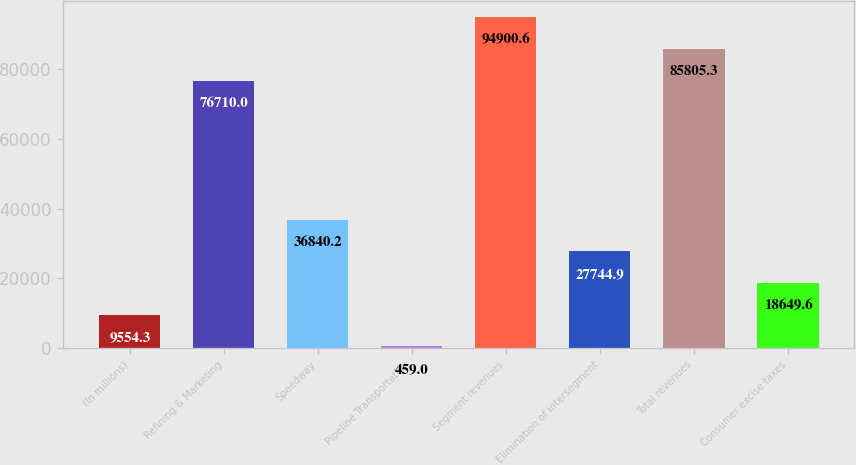Convert chart. <chart><loc_0><loc_0><loc_500><loc_500><bar_chart><fcel>(In millions)<fcel>Refining & Marketing<fcel>Speedway<fcel>Pipeline Transportation<fcel>Segment revenues<fcel>Elimination of intersegment<fcel>Total revenues<fcel>Consumer excise taxes<nl><fcel>9554.3<fcel>76710<fcel>36840.2<fcel>459<fcel>94900.6<fcel>27744.9<fcel>85805.3<fcel>18649.6<nl></chart> 